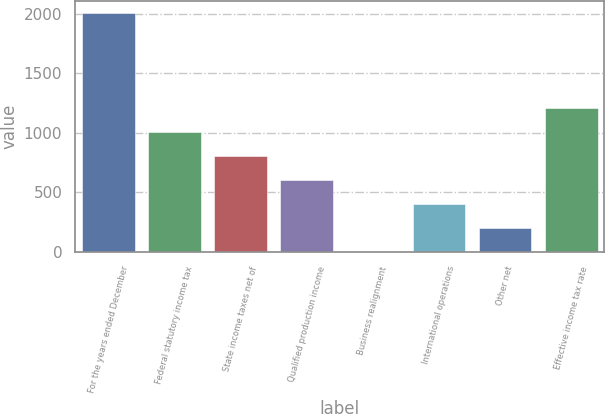<chart> <loc_0><loc_0><loc_500><loc_500><bar_chart><fcel>For the years ended December<fcel>Federal statutory income tax<fcel>State income taxes net of<fcel>Qualified production income<fcel>Business realignment<fcel>International operations<fcel>Other net<fcel>Effective income tax rate<nl><fcel>2008<fcel>1004.35<fcel>803.62<fcel>602.89<fcel>0.7<fcel>402.16<fcel>201.43<fcel>1205.08<nl></chart> 